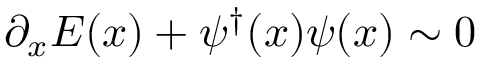Convert formula to latex. <formula><loc_0><loc_0><loc_500><loc_500>\partial _ { x } E ( x ) + \psi ^ { \dagger } ( x ) \psi ( x ) \sim 0</formula> 